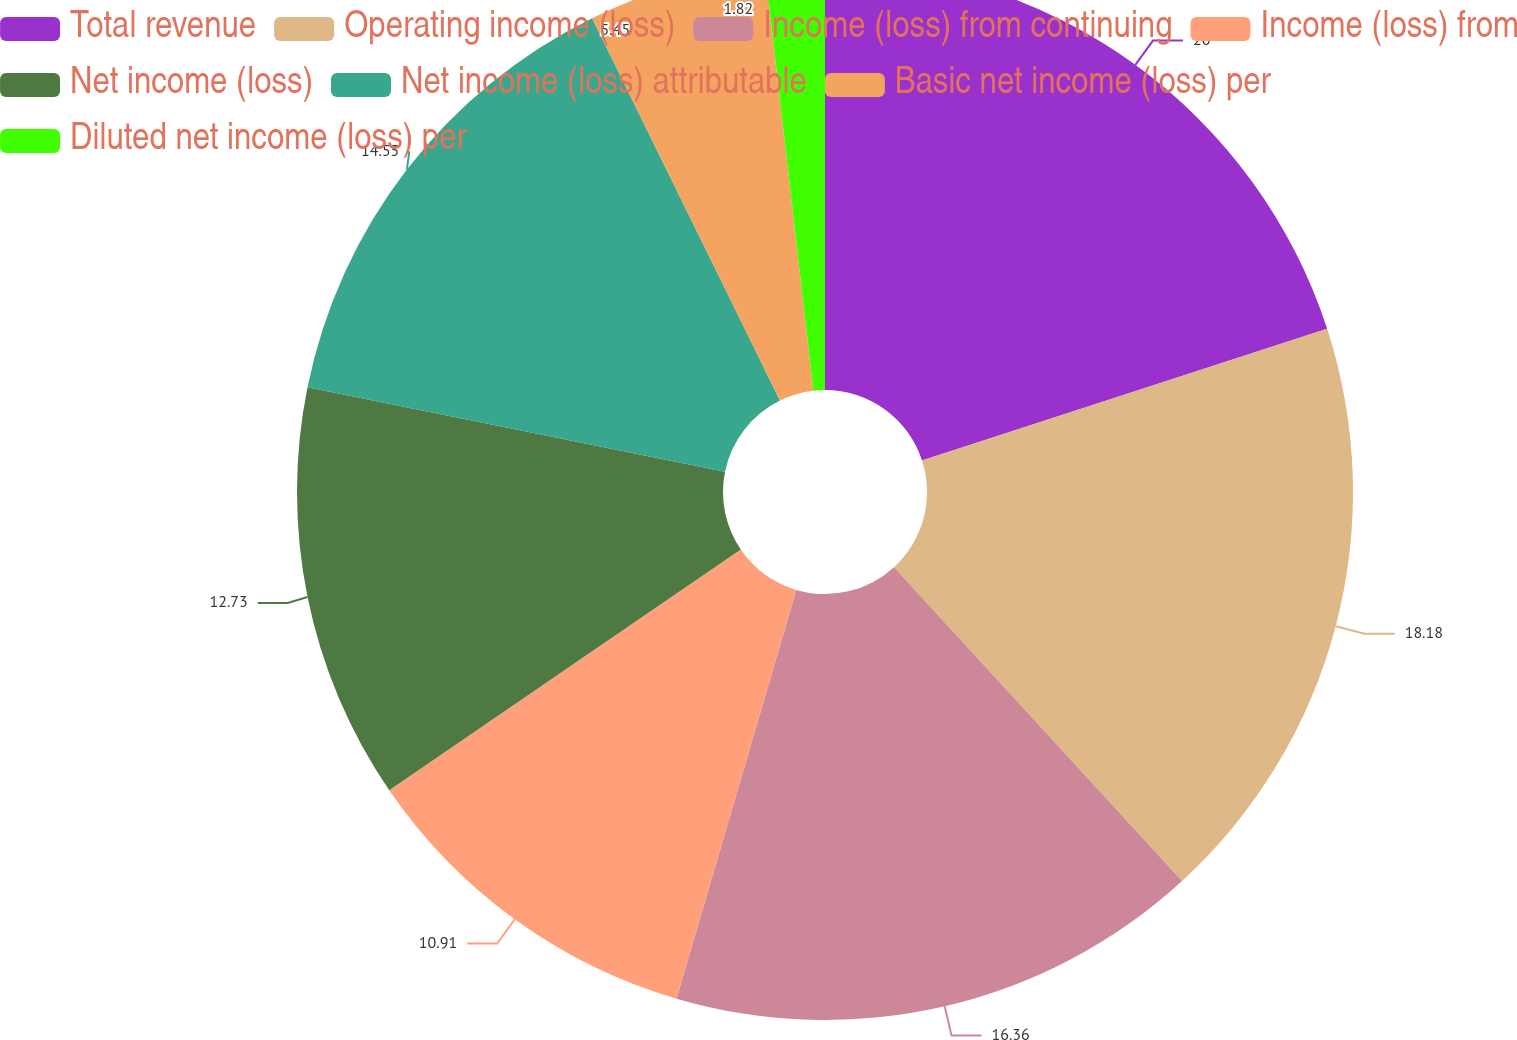<chart> <loc_0><loc_0><loc_500><loc_500><pie_chart><fcel>Total revenue<fcel>Operating income (loss)<fcel>Income (loss) from continuing<fcel>Income (loss) from<fcel>Net income (loss)<fcel>Net income (loss) attributable<fcel>Basic net income (loss) per<fcel>Diluted net income (loss) per<nl><fcel>20.0%<fcel>18.18%<fcel>16.36%<fcel>10.91%<fcel>12.73%<fcel>14.55%<fcel>5.45%<fcel>1.82%<nl></chart> 